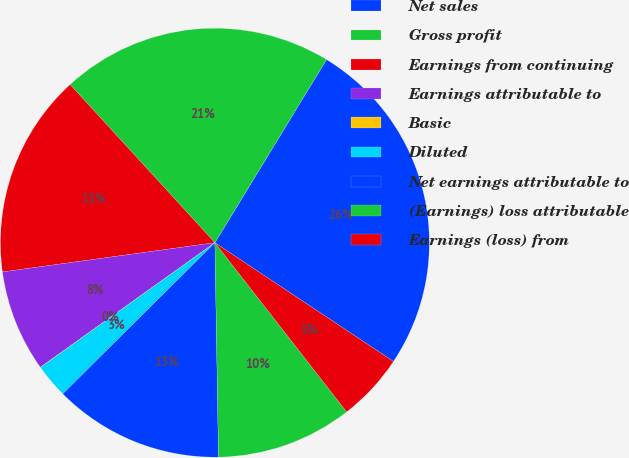Convert chart to OTSL. <chart><loc_0><loc_0><loc_500><loc_500><pie_chart><fcel>Net sales<fcel>Gross profit<fcel>Earnings from continuing<fcel>Earnings attributable to<fcel>Basic<fcel>Diluted<fcel>Net earnings attributable to<fcel>(Earnings) loss attributable<fcel>Earnings (loss) from<nl><fcel>25.63%<fcel>20.51%<fcel>15.38%<fcel>7.69%<fcel>0.01%<fcel>2.57%<fcel>12.82%<fcel>10.26%<fcel>5.13%<nl></chart> 